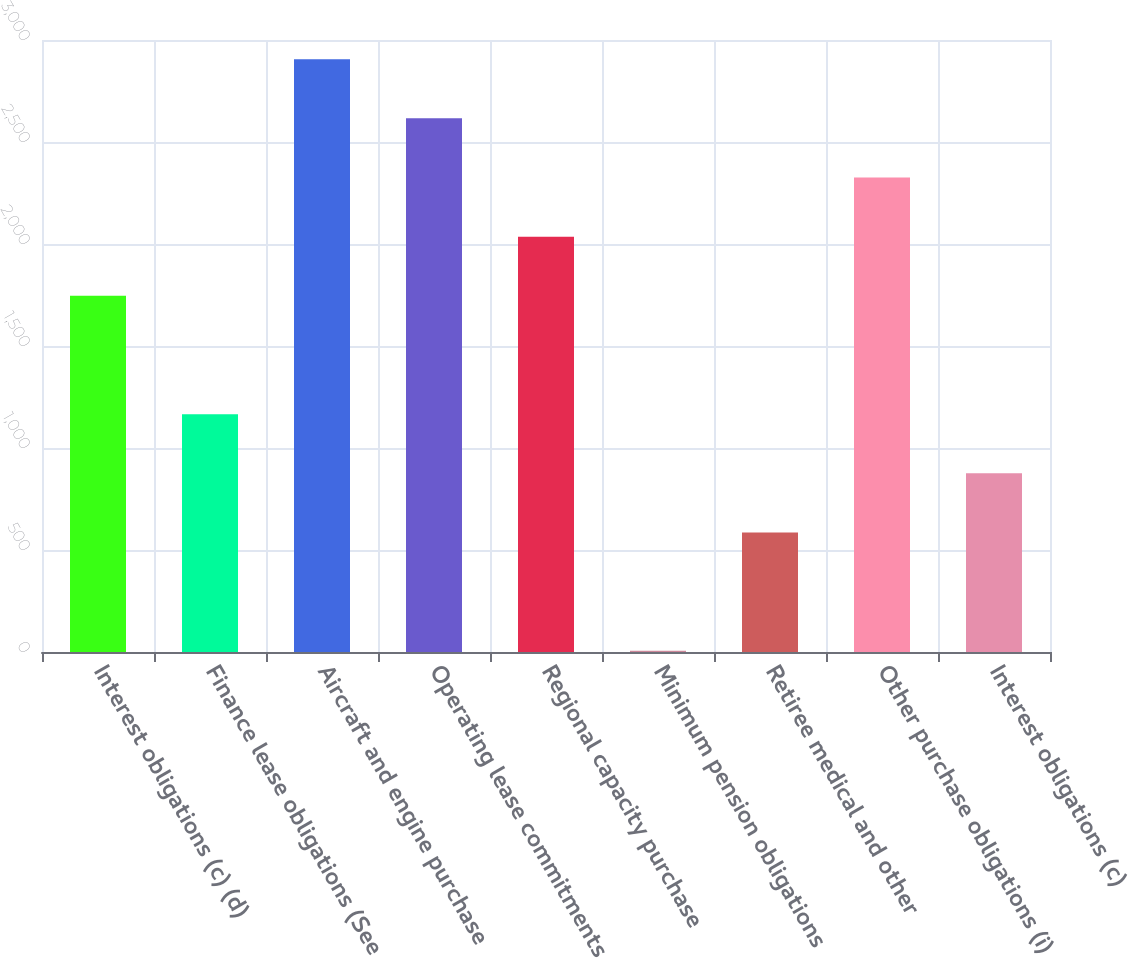<chart> <loc_0><loc_0><loc_500><loc_500><bar_chart><fcel>Interest obligations (c) (d)<fcel>Finance lease obligations (See<fcel>Aircraft and engine purchase<fcel>Operating lease commitments<fcel>Regional capacity purchase<fcel>Minimum pension obligations<fcel>Retiree medical and other<fcel>Other purchase obligations (i)<fcel>Interest obligations (c)<nl><fcel>1746<fcel>1166<fcel>2906<fcel>2616<fcel>2036<fcel>6<fcel>586<fcel>2326<fcel>876<nl></chart> 